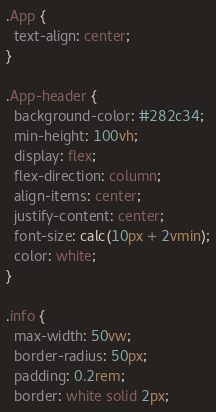Convert code to text. <code><loc_0><loc_0><loc_500><loc_500><_CSS_>.App {
  text-align: center;
}

.App-header {
  background-color: #282c34;
  min-height: 100vh;
  display: flex;
  flex-direction: column;
  align-items: center;
  justify-content: center;
  font-size: calc(10px + 2vmin);
  color: white;
}

.info {
  max-width: 50vw;
  border-radius: 50px;
  padding: 0.2rem;
  border: white solid 2px;</code> 